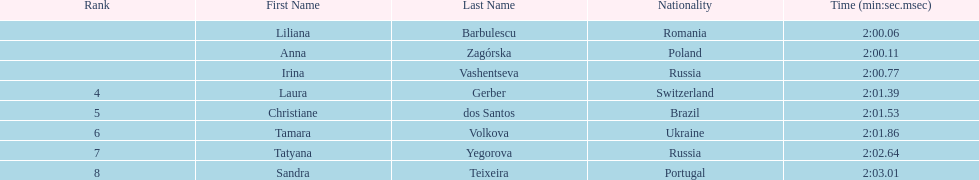Which country had the most finishers in the top 8? Russia. 